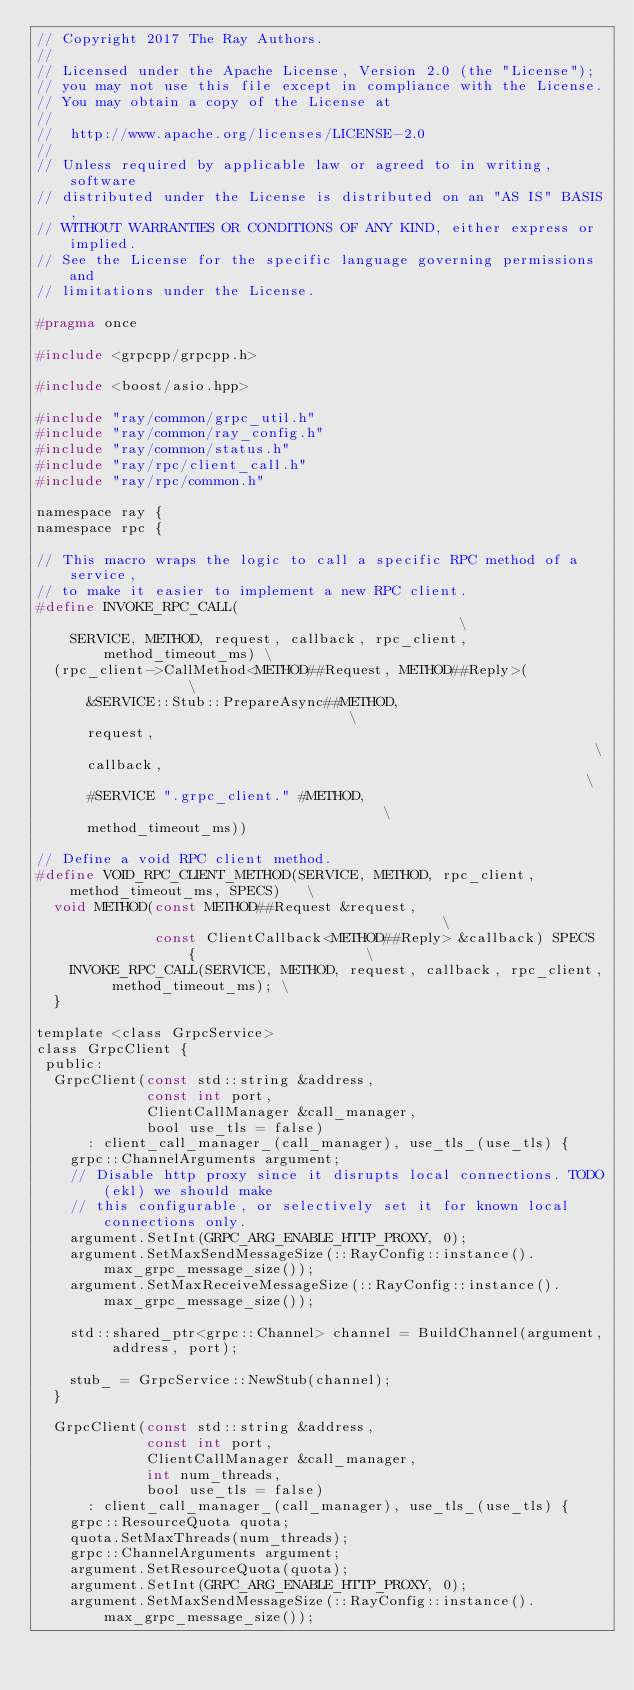Convert code to text. <code><loc_0><loc_0><loc_500><loc_500><_C_>// Copyright 2017 The Ray Authors.
//
// Licensed under the Apache License, Version 2.0 (the "License");
// you may not use this file except in compliance with the License.
// You may obtain a copy of the License at
//
//  http://www.apache.org/licenses/LICENSE-2.0
//
// Unless required by applicable law or agreed to in writing, software
// distributed under the License is distributed on an "AS IS" BASIS,
// WITHOUT WARRANTIES OR CONDITIONS OF ANY KIND, either express or implied.
// See the License for the specific language governing permissions and
// limitations under the License.

#pragma once

#include <grpcpp/grpcpp.h>

#include <boost/asio.hpp>

#include "ray/common/grpc_util.h"
#include "ray/common/ray_config.h"
#include "ray/common/status.h"
#include "ray/rpc/client_call.h"
#include "ray/rpc/common.h"

namespace ray {
namespace rpc {

// This macro wraps the logic to call a specific RPC method of a service,
// to make it easier to implement a new RPC client.
#define INVOKE_RPC_CALL(                                               \
    SERVICE, METHOD, request, callback, rpc_client, method_timeout_ms) \
  (rpc_client->CallMethod<METHOD##Request, METHOD##Reply>(             \
      &SERVICE::Stub::PrepareAsync##METHOD,                            \
      request,                                                         \
      callback,                                                        \
      #SERVICE ".grpc_client." #METHOD,                                \
      method_timeout_ms))

// Define a void RPC client method.
#define VOID_RPC_CLIENT_METHOD(SERVICE, METHOD, rpc_client, method_timeout_ms, SPECS)   \
  void METHOD(const METHOD##Request &request,                                           \
              const ClientCallback<METHOD##Reply> &callback) SPECS {                    \
    INVOKE_RPC_CALL(SERVICE, METHOD, request, callback, rpc_client, method_timeout_ms); \
  }

template <class GrpcService>
class GrpcClient {
 public:
  GrpcClient(const std::string &address,
             const int port,
             ClientCallManager &call_manager,
             bool use_tls = false)
      : client_call_manager_(call_manager), use_tls_(use_tls) {
    grpc::ChannelArguments argument;
    // Disable http proxy since it disrupts local connections. TODO(ekl) we should make
    // this configurable, or selectively set it for known local connections only.
    argument.SetInt(GRPC_ARG_ENABLE_HTTP_PROXY, 0);
    argument.SetMaxSendMessageSize(::RayConfig::instance().max_grpc_message_size());
    argument.SetMaxReceiveMessageSize(::RayConfig::instance().max_grpc_message_size());

    std::shared_ptr<grpc::Channel> channel = BuildChannel(argument, address, port);

    stub_ = GrpcService::NewStub(channel);
  }

  GrpcClient(const std::string &address,
             const int port,
             ClientCallManager &call_manager,
             int num_threads,
             bool use_tls = false)
      : client_call_manager_(call_manager), use_tls_(use_tls) {
    grpc::ResourceQuota quota;
    quota.SetMaxThreads(num_threads);
    grpc::ChannelArguments argument;
    argument.SetResourceQuota(quota);
    argument.SetInt(GRPC_ARG_ENABLE_HTTP_PROXY, 0);
    argument.SetMaxSendMessageSize(::RayConfig::instance().max_grpc_message_size());</code> 